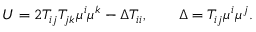Convert formula to latex. <formula><loc_0><loc_0><loc_500><loc_500>U = 2 T _ { i j } T _ { j k } \mu ^ { i } \mu ^ { k } - \Delta T _ { i i } , \quad \Delta = T _ { i j } \mu ^ { i } \mu ^ { j } .</formula> 